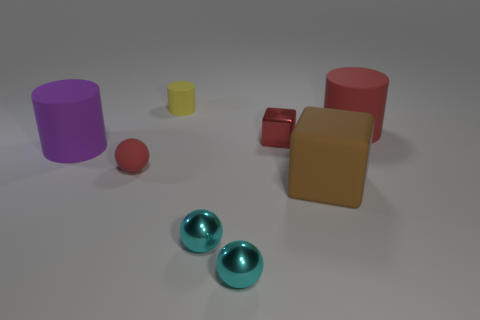Subtract all green cylinders. How many cyan balls are left? 2 Subtract all cyan metallic balls. How many balls are left? 1 Add 2 brown rubber blocks. How many objects exist? 10 Subtract 0 gray cylinders. How many objects are left? 8 Subtract all balls. How many objects are left? 5 Subtract all gray balls. Subtract all blue cylinders. How many balls are left? 3 Subtract all rubber objects. Subtract all rubber cylinders. How many objects are left? 0 Add 8 red matte cylinders. How many red matte cylinders are left? 9 Add 7 large yellow cylinders. How many large yellow cylinders exist? 7 